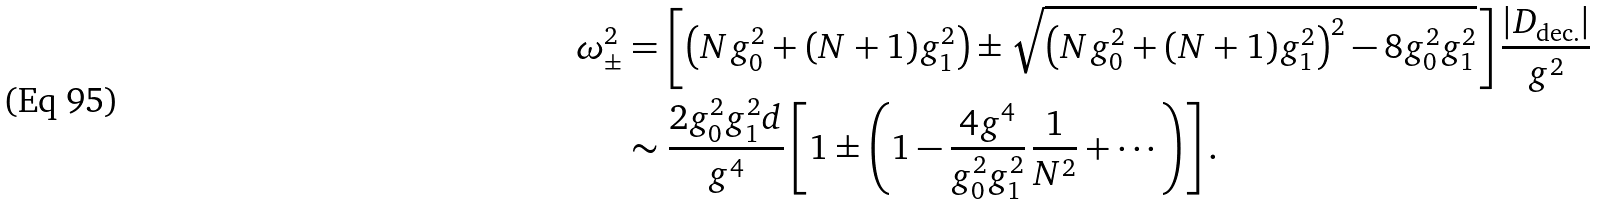<formula> <loc_0><loc_0><loc_500><loc_500>\omega _ { \pm } ^ { 2 } & = \left [ \left ( N g _ { 0 } ^ { 2 } + ( N + 1 ) g _ { 1 } ^ { 2 } \right ) \pm \sqrt { \left ( N g _ { 0 } ^ { 2 } + ( N + 1 ) g _ { 1 } ^ { 2 } \right ) ^ { 2 } - 8 g _ { 0 } ^ { 2 } g _ { 1 } ^ { 2 } } \right ] \frac { | D _ { \text {dec.} } | } { g ^ { 2 } } \\ & \sim \frac { 2 g _ { 0 } ^ { 2 } g _ { 1 } ^ { 2 } d } { g ^ { 4 } } \left [ 1 \pm \left ( 1 - \frac { 4 g ^ { 4 } } { g _ { 0 } ^ { 2 } g _ { 1 } ^ { 2 } } \, \frac { 1 } { N ^ { 2 } } + \cdots \right ) \right ] .</formula> 